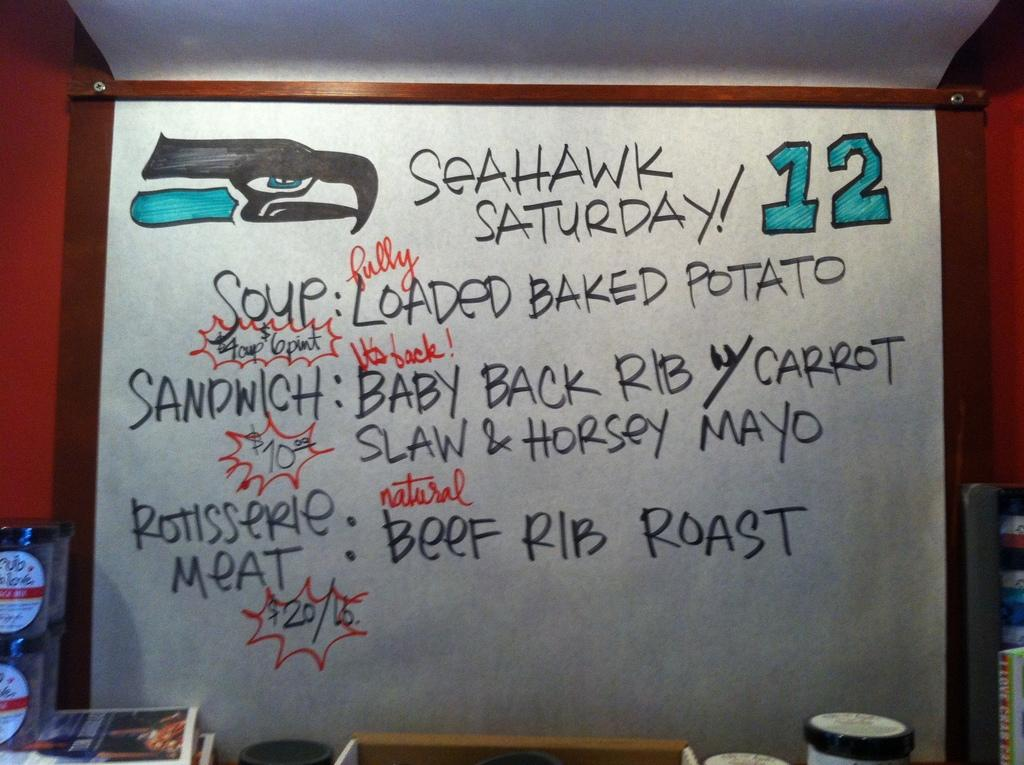Provide a one-sentence caption for the provided image. The specials today are called Seahawk Saturday Specials. 